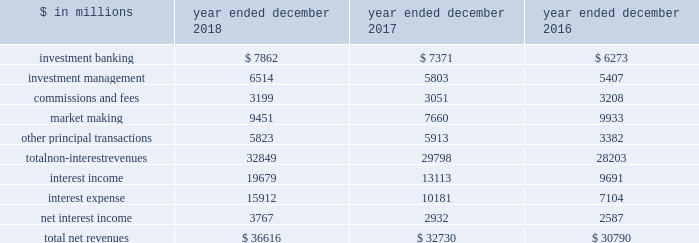The goldman sachs group , inc .
And subsidiaries management 2019s discussion and analysis net revenues the table below presents net revenues by line item. .
In the table above : 2030 investment banking consists of revenues ( excluding net interest ) from financial advisory and underwriting assignments , as well as derivative transactions directly related to these assignments .
These activities are included in our investment banking segment .
2030 investment management consists of revenues ( excluding net interest ) from providing investment management services to a diverse set of clients , as well as wealth advisory services and certain transaction services to high-net-worth individuals and families .
These activities are included in our investment management segment .
2030 commissions and fees consists of revenues from executing and clearing client transactions on major stock , options and futures exchanges worldwide , as well as over-the-counter ( otc ) transactions .
These activities are included in our institutional client services and investment management segments .
2030 market making consists of revenues ( excluding net interest ) from client execution activities related to making markets in interest rate products , credit products , mortgages , currencies , commodities and equity products .
These activities are included in our institutional client services segment .
2030 other principal transactions consists of revenues ( excluding net interest ) from our investing activities and the origination of loans to provide financing to clients .
In addition , other principal transactions includes revenues related to our consolidated investments .
These activities are included in our investing & lending segment .
Provision for credit losses , previously reported in other principal transactions revenues , is now reported as a separate line item in the consolidated statements of earnings .
Previously reported amounts have been conformed to the current presentation .
Operating environment .
During 2018 , our market- making activities reflected generally higher levels of volatility and improved client activity , compared with a low volatility environment in 2017 .
In investment banking , industry-wide mergers and acquisitions volumes increased compared with 2017 , while industry-wide underwriting transactions decreased .
Our other principal transactions revenues benefited from company-specific events , including sales , and strong corporate performance , while investments in public equities reflected losses , as global equity prices generally decreased in 2018 , particularly towards the end of the year .
In investment management , our assets under supervision increased reflecting net inflows in liquidity products , fixed income assets and equity assets , partially offset by depreciation in client assets , primarily in equity assets .
If market-making or investment banking activity levels decline , or assets under supervision decline , or asset prices continue to decline , net revenues would likely be negatively impacted .
See 201csegment operating results 201d for further information about the operating environment and material trends and uncertainties that may impact our results of operations .
During 2017 , generally higher asset prices and tighter credit spreads were supportive of industry-wide underwriting activities , investment management performance and other principal transactions .
However , low levels of volatility in equity , fixed income , currency and commodity markets continued to negatively affect our market-making activities .
2018 versus 2017 net revenues in the consolidated statements of earnings were $ 36.62 billion for 2018 , 12% ( 12 % ) higher than 2017 , primarily due to significantly higher market making revenues and net interest income , as well as higher investment management revenues and investment banking revenues .
Non-interest revenues .
Investment banking revenues in the consolidated statements of earnings were $ 7.86 billion for 2018 , 7% ( 7 % ) higher than 2017 .
Revenues in financial advisory were higher , reflecting an increase in industry-wide completed mergers and acquisitions volumes .
Revenues in underwriting were slightly higher , due to significantly higher revenues in equity underwriting , driven by initial public offerings , partially offset by lower revenues in debt underwriting , reflecting a decline in leveraged finance activity .
Investment management revenues in the consolidated statements of earnings were $ 6.51 billion for 2018 , 12% ( 12 % ) higher than 2017 , primarily due to significantly higher incentive fees , as a result of harvesting .
Management and other fees were also higher , reflecting higher average assets under supervision and the impact of the recently adopted revenue recognition standard , partially offset by shifts in the mix of client assets and strategies .
See note 3 to the consolidated financial statements for further information about asu no .
2014-09 , 201crevenue from contracts with customers ( topic 606 ) . 201d 52 goldman sachs 2018 form 10-k .
What is the growth rate in net revenues in 2018? 
Computations: ((36616 - 32730) / 32730)
Answer: 0.11873. 